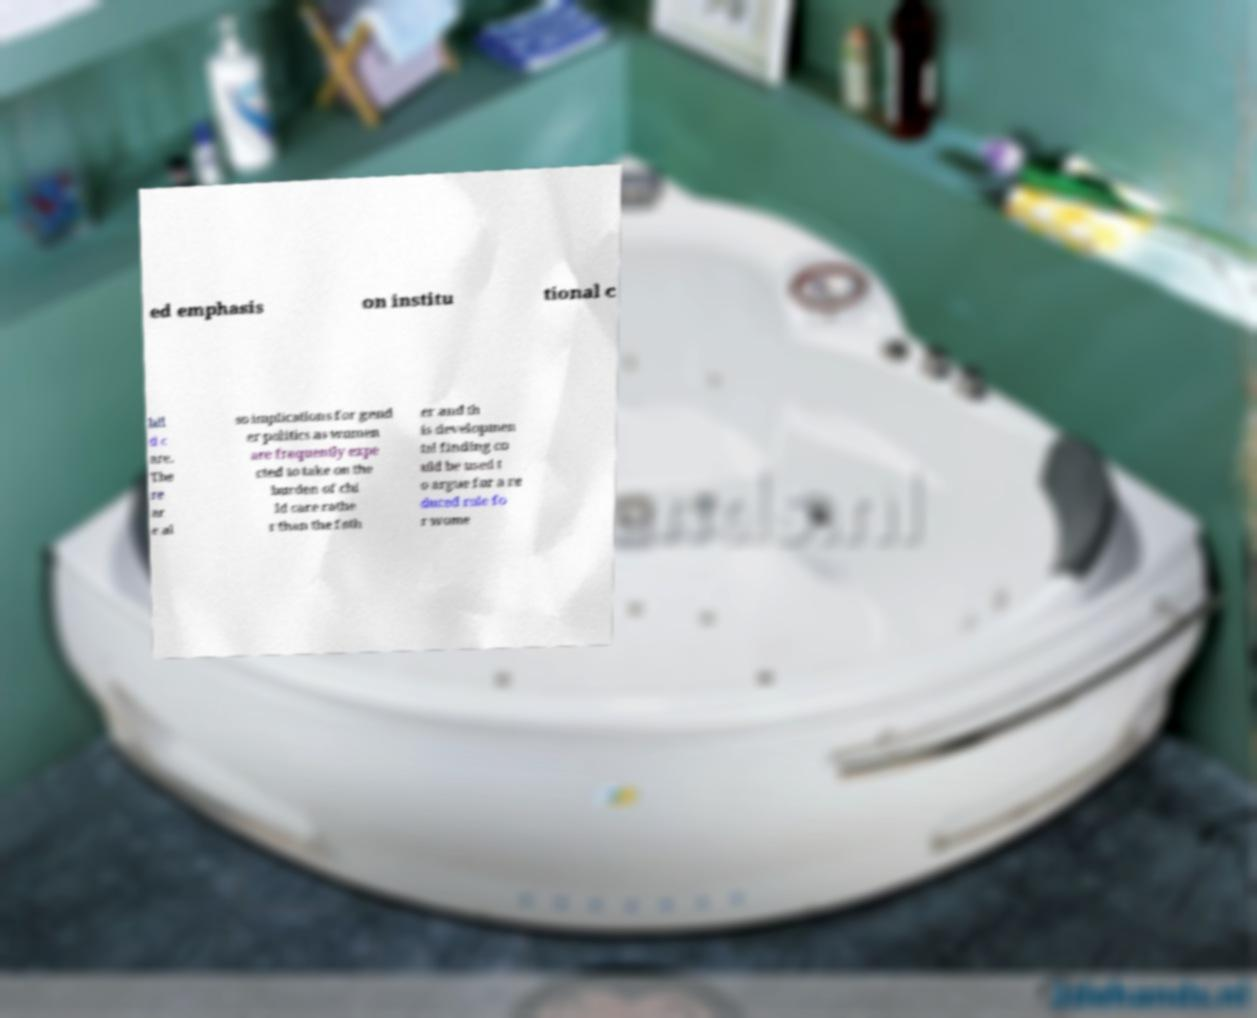For documentation purposes, I need the text within this image transcribed. Could you provide that? ed emphasis on institu tional c hil d c are. The re ar e al so implications for gend er politics as women are frequently expe cted to take on the burden of chi ld care rathe r than the fath er and th is developmen tal finding co uld be used t o argue for a re duced role fo r wome 